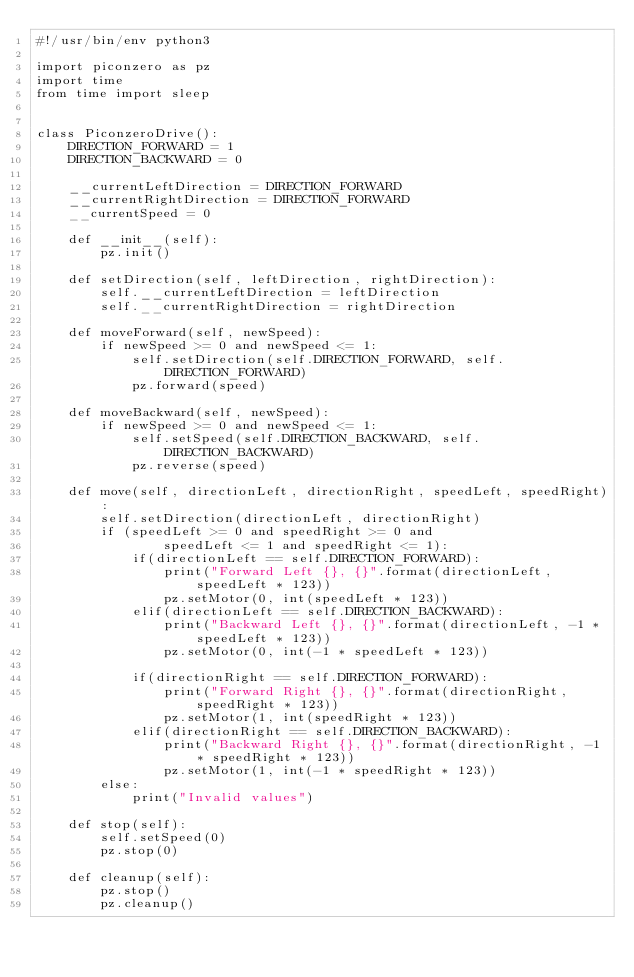<code> <loc_0><loc_0><loc_500><loc_500><_Python_>#!/usr/bin/env python3

import piconzero as pz
import time
from time import sleep


class PiconzeroDrive():
    DIRECTION_FORWARD = 1
    DIRECTION_BACKWARD = 0

    __currentLeftDirection = DIRECTION_FORWARD
    __currentRightDirection = DIRECTION_FORWARD
    __currentSpeed = 0

    def __init__(self):
        pz.init()

    def setDirection(self, leftDirection, rightDirection):
        self.__currentLeftDirection = leftDirection
        self.__currentRightDirection = rightDirection

    def moveForward(self, newSpeed):
        if newSpeed >= 0 and newSpeed <= 1:
            self.setDirection(self.DIRECTION_FORWARD, self.DIRECTION_FORWARD)
            pz.forward(speed)

    def moveBackward(self, newSpeed):
        if newSpeed >= 0 and newSpeed <= 1:
            self.setSpeed(self.DIRECTION_BACKWARD, self.DIRECTION_BACKWARD)
            pz.reverse(speed)

    def move(self, directionLeft, directionRight, speedLeft, speedRight):
        self.setDirection(directionLeft, directionRight)
        if (speedLeft >= 0 and speedRight >= 0 and
                speedLeft <= 1 and speedRight <= 1):
            if(directionLeft == self.DIRECTION_FORWARD):
                print("Forward Left {}, {}".format(directionLeft, speedLeft * 123))
                pz.setMotor(0, int(speedLeft * 123))
            elif(directionLeft == self.DIRECTION_BACKWARD):
                print("Backward Left {}, {}".format(directionLeft, -1 * speedLeft * 123))
                pz.setMotor(0, int(-1 * speedLeft * 123))

            if(directionRight == self.DIRECTION_FORWARD):
                print("Forward Right {}, {}".format(directionRight, speedRight * 123))
                pz.setMotor(1, int(speedRight * 123))
            elif(directionRight == self.DIRECTION_BACKWARD):
                print("Backward Right {}, {}".format(directionRight, -1 * speedRight * 123))
                pz.setMotor(1, int(-1 * speedRight * 123))
        else:
            print("Invalid values")

    def stop(self):
        self.setSpeed(0)
        pz.stop(0)

    def cleanup(self):
        pz.stop()
        pz.cleanup()
</code> 